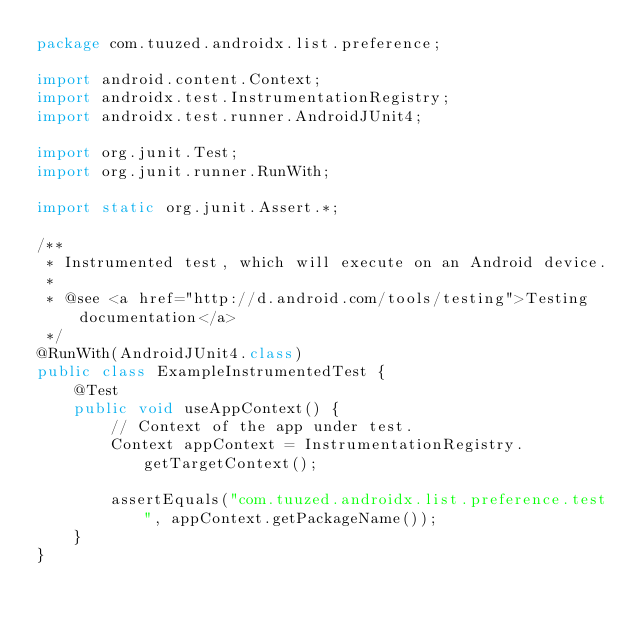<code> <loc_0><loc_0><loc_500><loc_500><_Java_>package com.tuuzed.androidx.list.preference;

import android.content.Context;
import androidx.test.InstrumentationRegistry;
import androidx.test.runner.AndroidJUnit4;

import org.junit.Test;
import org.junit.runner.RunWith;

import static org.junit.Assert.*;

/**
 * Instrumented test, which will execute on an Android device.
 *
 * @see <a href="http://d.android.com/tools/testing">Testing documentation</a>
 */
@RunWith(AndroidJUnit4.class)
public class ExampleInstrumentedTest {
    @Test
    public void useAppContext() {
        // Context of the app under test.
        Context appContext = InstrumentationRegistry.getTargetContext();

        assertEquals("com.tuuzed.androidx.list.preference.test", appContext.getPackageName());
    }
}
</code> 